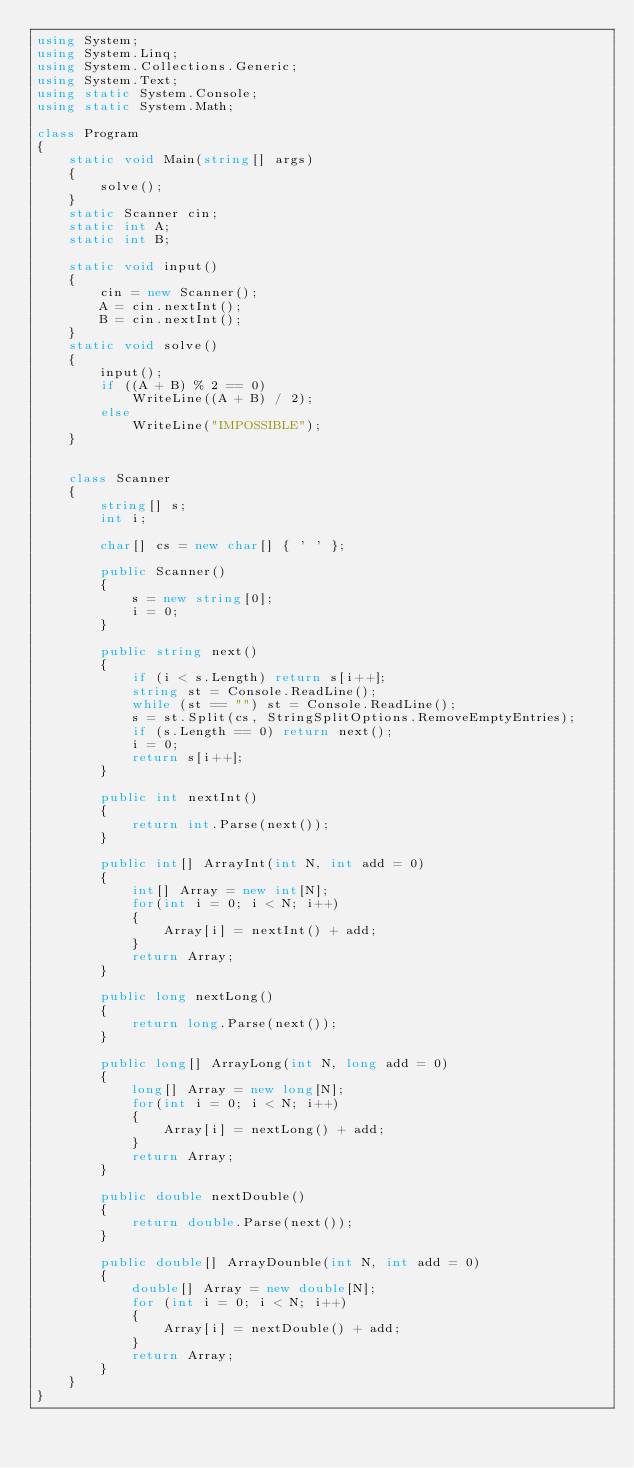<code> <loc_0><loc_0><loc_500><loc_500><_C#_>using System;
using System.Linq;
using System.Collections.Generic;
using System.Text;
using static System.Console;
using static System.Math;

class Program
{
    static void Main(string[] args)
    {
        solve();
    }
    static Scanner cin;
    static int A;
    static int B;

    static void input()
    {
        cin = new Scanner();
        A = cin.nextInt();
        B = cin.nextInt();
    }
    static void solve()
    {
        input();
        if ((A + B) % 2 == 0)
            WriteLine((A + B) / 2);
        else
            WriteLine("IMPOSSIBLE");
    }

    
    class Scanner
    {
        string[] s;
        int i;

        char[] cs = new char[] { ' ' };

        public Scanner()
        {
            s = new string[0];
            i = 0;
        }
        
        public string next()
        {
            if (i < s.Length) return s[i++];
            string st = Console.ReadLine();
            while (st == "") st = Console.ReadLine();
            s = st.Split(cs, StringSplitOptions.RemoveEmptyEntries);
            if (s.Length == 0) return next();
            i = 0;
            return s[i++];
        }

        public int nextInt()
        {
            return int.Parse(next());
        }

        public int[] ArrayInt(int N, int add = 0)
        {
            int[] Array = new int[N];
            for(int i = 0; i < N; i++)
            {
                Array[i] = nextInt() + add;
            }
            return Array;
        }

        public long nextLong()
        {
            return long.Parse(next());
        }

        public long[] ArrayLong(int N, long add = 0)
        {
            long[] Array = new long[N];
            for(int i = 0; i < N; i++)
            {
                Array[i] = nextLong() + add;
            }
            return Array;
        }

        public double nextDouble()
        {
            return double.Parse(next());
        }

        public double[] ArrayDounble(int N, int add = 0)
        {
            double[] Array = new double[N];
            for (int i = 0; i < N; i++)
            {
                Array[i] = nextDouble() + add;
            }
            return Array;
        }
    }
}</code> 